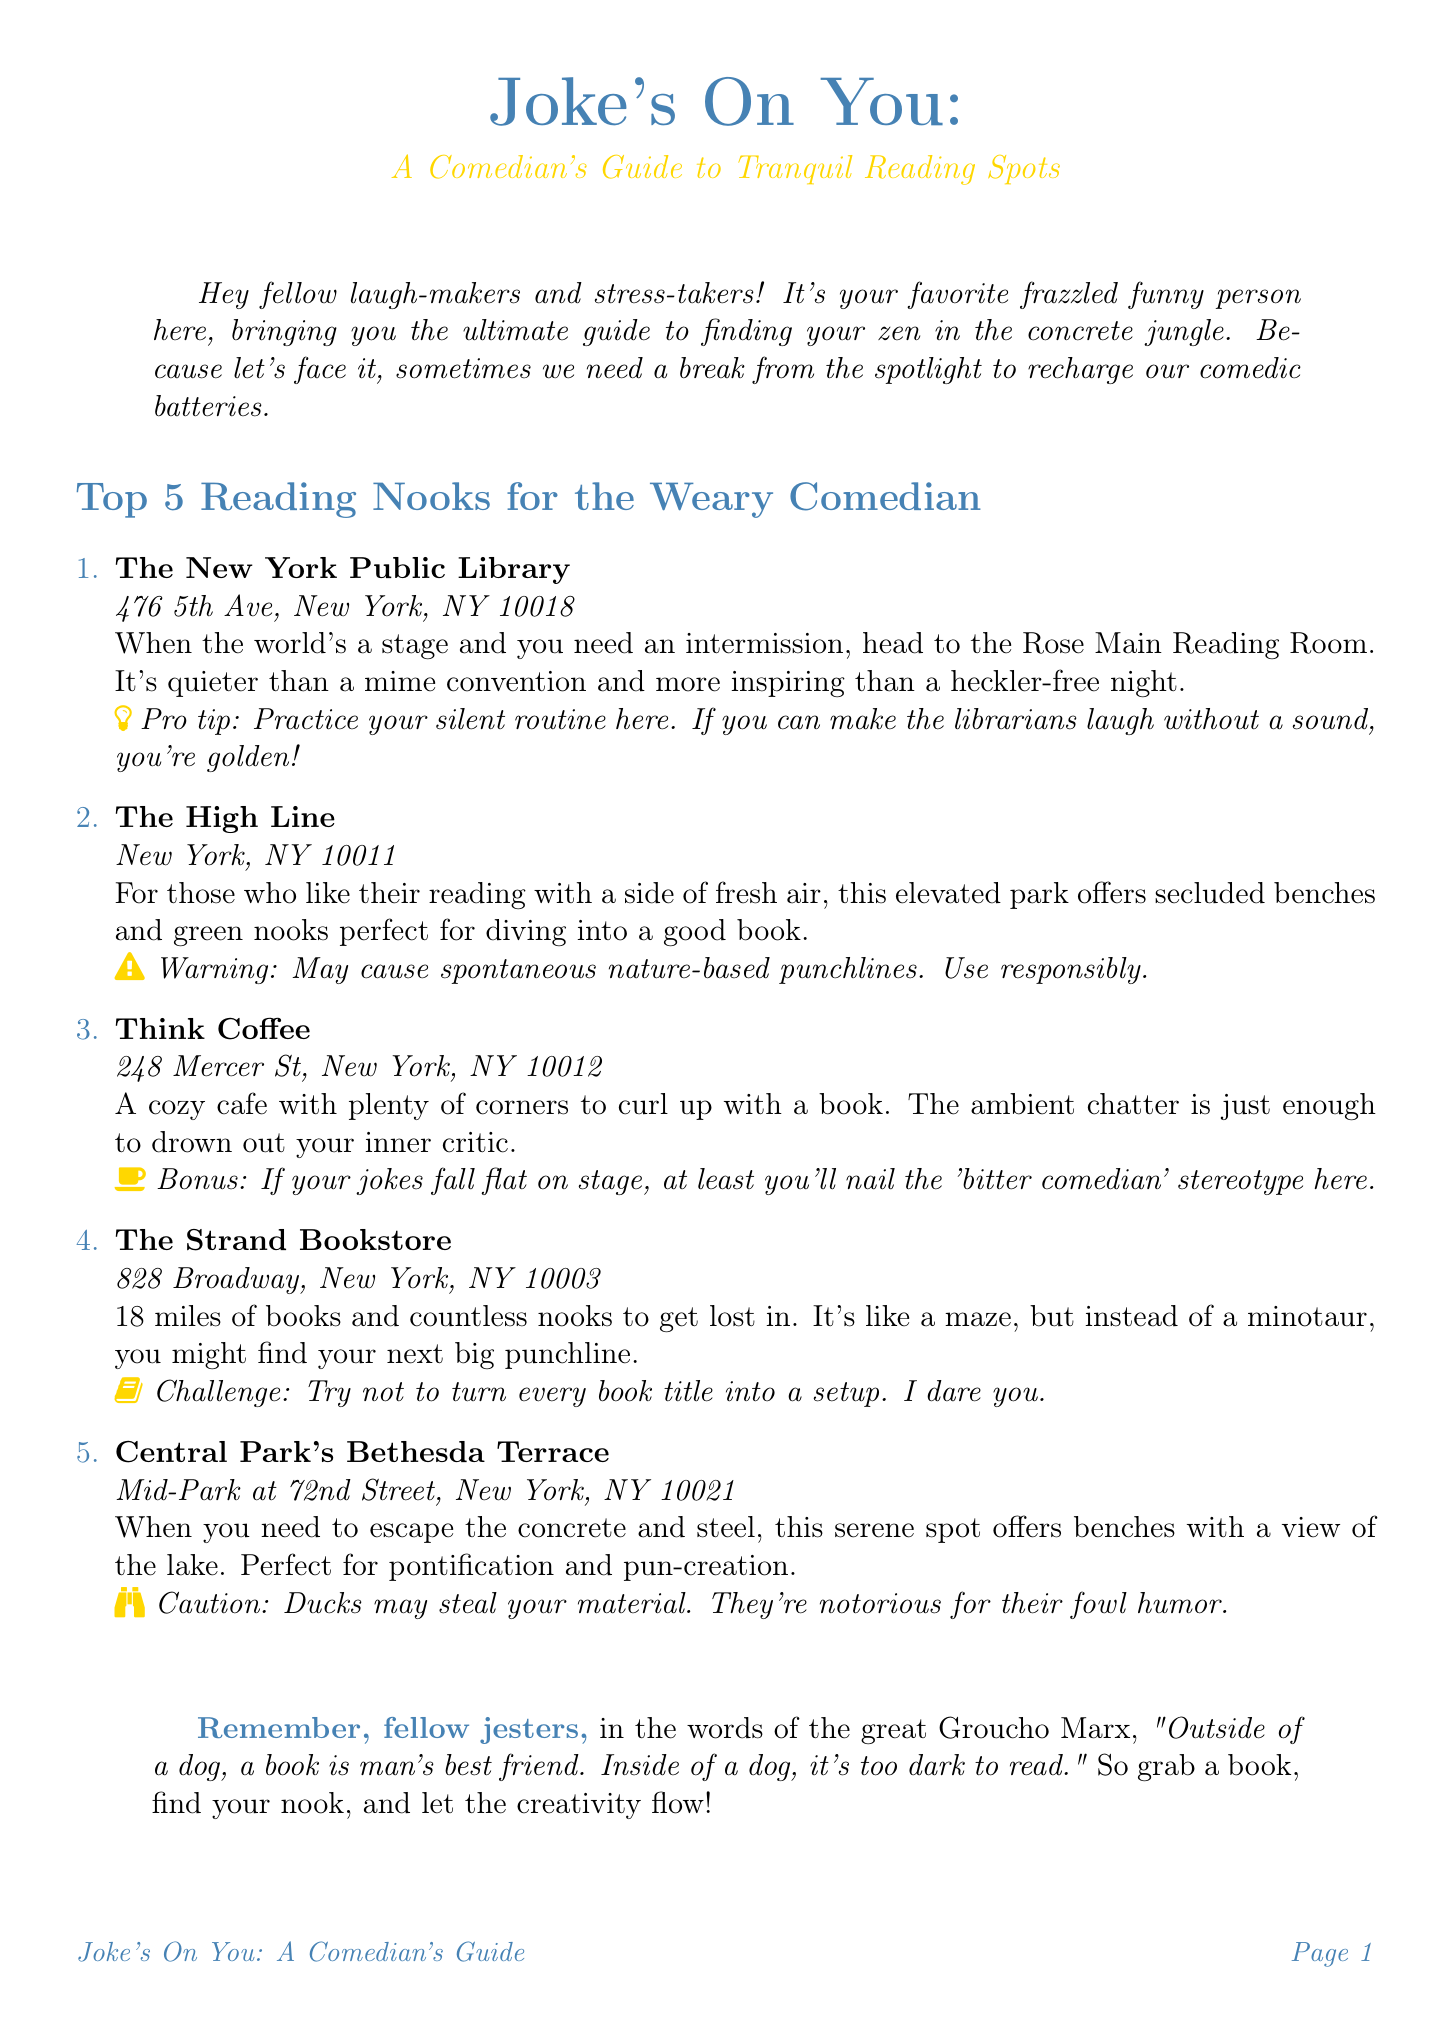What is the title of the newsletter? The title is clearly stated at the beginning of the document.
Answer: Joke's On You: A Comedian's Guide to Tranquil Reading Spots What is the address of Think Coffee? The document lists the addresses of various recommended reading spots.
Answer: 248 Mercer St, New York, NY 10012 How many reading nooks are featured in the newsletter? The document lists a total of five different reading nooks.
Answer: 5 Which location is described as having “18 miles of books”? The description identifies which specific nook is known for a large selection of books.
Answer: The Strand Bookstore What comedic twist is mentioned for Central Park's Bethesda Terrace? Each reading nook includes a lighthearted twist or warning associated with it.
Answer: Ducks may steal your material What quote is attributed to Groucho Marx in the conclusion? The conclusion includes a humorous quote relevant to reading and companionship.
Answer: Outside of a dog, a book is man's best friend. Inside of a dog, it's too dark to read What kind of atmosphere does The High Line provide for reading? The document describes the atmosphere at each location to help readers find inspiration.
Answer: Fresh air Who is the author of the guide? The document includes information about who created the newsletter.
Answer: A comedian What is a pro tip for The New York Public Library? Each reading nook contains a special tip or advice for comedians.
Answer: Practice your silent routine here 